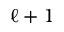<formula> <loc_0><loc_0><loc_500><loc_500>\ell + 1</formula> 